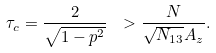<formula> <loc_0><loc_0><loc_500><loc_500>\tau _ { c } = \frac { 2 } { \sqrt { 1 - p ^ { 2 } } } \ > \frac { N } { \sqrt { N _ { 1 3 } } A _ { z } } .</formula> 